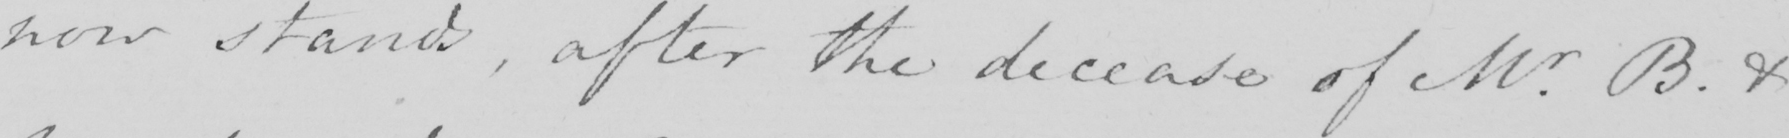Can you read and transcribe this handwriting? now stands , after the decease of Mr . B . & 